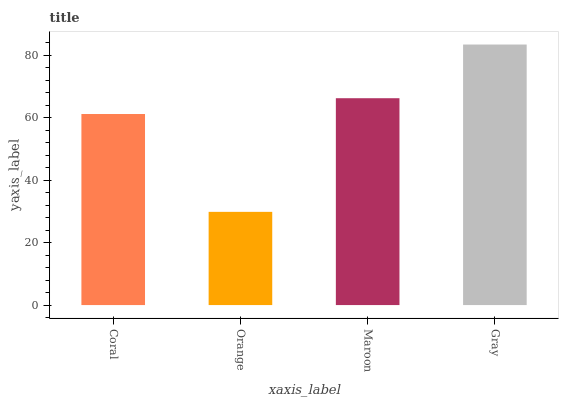Is Orange the minimum?
Answer yes or no. Yes. Is Gray the maximum?
Answer yes or no. Yes. Is Maroon the minimum?
Answer yes or no. No. Is Maroon the maximum?
Answer yes or no. No. Is Maroon greater than Orange?
Answer yes or no. Yes. Is Orange less than Maroon?
Answer yes or no. Yes. Is Orange greater than Maroon?
Answer yes or no. No. Is Maroon less than Orange?
Answer yes or no. No. Is Maroon the high median?
Answer yes or no. Yes. Is Coral the low median?
Answer yes or no. Yes. Is Coral the high median?
Answer yes or no. No. Is Orange the low median?
Answer yes or no. No. 